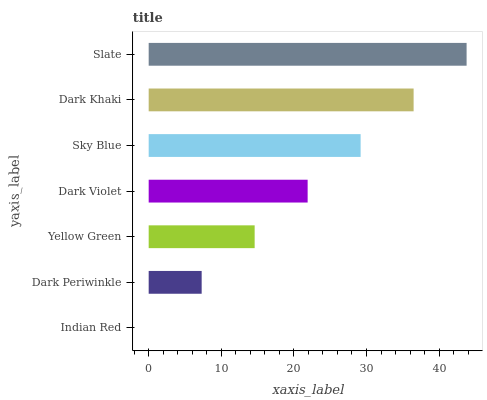Is Indian Red the minimum?
Answer yes or no. Yes. Is Slate the maximum?
Answer yes or no. Yes. Is Dark Periwinkle the minimum?
Answer yes or no. No. Is Dark Periwinkle the maximum?
Answer yes or no. No. Is Dark Periwinkle greater than Indian Red?
Answer yes or no. Yes. Is Indian Red less than Dark Periwinkle?
Answer yes or no. Yes. Is Indian Red greater than Dark Periwinkle?
Answer yes or no. No. Is Dark Periwinkle less than Indian Red?
Answer yes or no. No. Is Dark Violet the high median?
Answer yes or no. Yes. Is Dark Violet the low median?
Answer yes or no. Yes. Is Yellow Green the high median?
Answer yes or no. No. Is Yellow Green the low median?
Answer yes or no. No. 